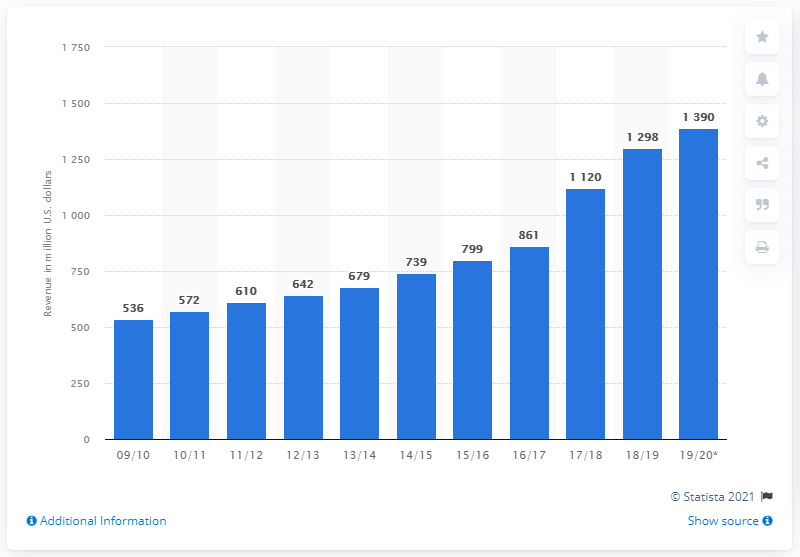Outline some significant characteristics in this image. The NBA generated $129.8 million from sponsorship in the 2018/19 season. 